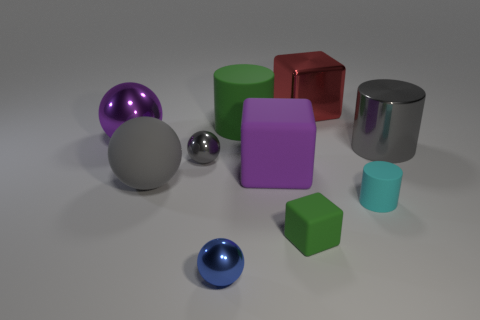What is the shape of the tiny object that is the same color as the big matte cylinder?
Offer a very short reply. Cube. There is a cylinder that is both right of the small green block and behind the small gray ball; what is its color?
Provide a short and direct response. Gray. Are there any large gray shiny cylinders left of the big rubber object behind the sphere that is behind the gray cylinder?
Make the answer very short. No. What number of things are either large green rubber spheres or purple things?
Provide a short and direct response. 2. Do the tiny gray object and the cylinder behind the gray metallic cylinder have the same material?
Your response must be concise. No. Is there anything else of the same color as the small cylinder?
Your response must be concise. No. What number of objects are large things in front of the purple cube or objects in front of the tiny gray sphere?
Offer a very short reply. 5. The tiny thing that is in front of the cyan object and behind the small blue ball has what shape?
Your answer should be very brief. Cube. How many small gray shiny objects are in front of the block that is behind the big purple metallic sphere?
Your answer should be compact. 1. What number of objects are either small things that are right of the small green rubber object or big yellow objects?
Provide a succinct answer. 1. 